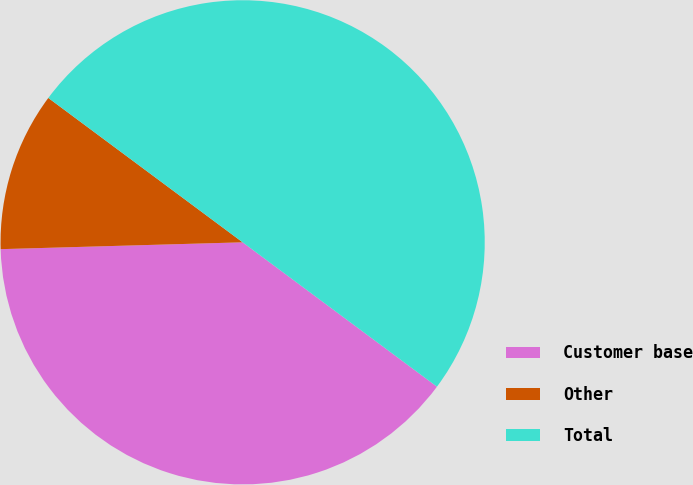<chart> <loc_0><loc_0><loc_500><loc_500><pie_chart><fcel>Customer base<fcel>Other<fcel>Total<nl><fcel>39.38%<fcel>10.62%<fcel>50.0%<nl></chart> 